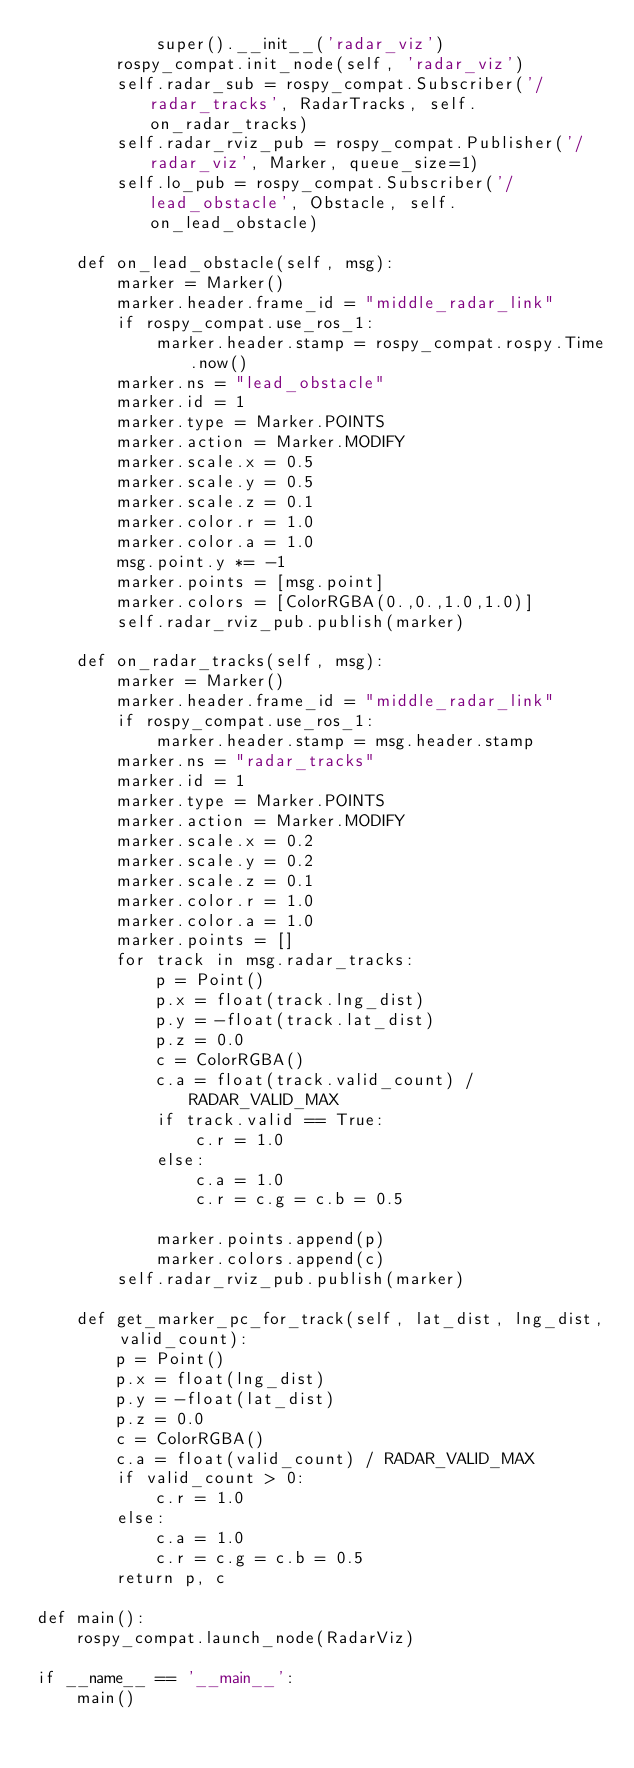<code> <loc_0><loc_0><loc_500><loc_500><_Python_>            super().__init__('radar_viz')
        rospy_compat.init_node(self, 'radar_viz')
        self.radar_sub = rospy_compat.Subscriber('/radar_tracks', RadarTracks, self.on_radar_tracks)
        self.radar_rviz_pub = rospy_compat.Publisher('/radar_viz', Marker, queue_size=1)
        self.lo_pub = rospy_compat.Subscriber('/lead_obstacle', Obstacle, self.on_lead_obstacle)

    def on_lead_obstacle(self, msg):
        marker = Marker()
        marker.header.frame_id = "middle_radar_link"
        if rospy_compat.use_ros_1:
            marker.header.stamp = rospy_compat.rospy.Time.now()
        marker.ns = "lead_obstacle"
        marker.id = 1
        marker.type = Marker.POINTS
        marker.action = Marker.MODIFY
        marker.scale.x = 0.5
        marker.scale.y = 0.5
        marker.scale.z = 0.1
        marker.color.r = 1.0
        marker.color.a = 1.0
        msg.point.y *= -1
        marker.points = [msg.point]
        marker.colors = [ColorRGBA(0.,0.,1.0,1.0)]
        self.radar_rviz_pub.publish(marker)

    def on_radar_tracks(self, msg):
        marker = Marker()
        marker.header.frame_id = "middle_radar_link"
        if rospy_compat.use_ros_1:
            marker.header.stamp = msg.header.stamp
        marker.ns = "radar_tracks"
        marker.id = 1
        marker.type = Marker.POINTS
        marker.action = Marker.MODIFY
        marker.scale.x = 0.2
        marker.scale.y = 0.2
        marker.scale.z = 0.1
        marker.color.r = 1.0
        marker.color.a = 1.0
        marker.points = []
        for track in msg.radar_tracks:
            p = Point()
            p.x = float(track.lng_dist)
            p.y = -float(track.lat_dist)
            p.z = 0.0
            c = ColorRGBA()
            c.a = float(track.valid_count) / RADAR_VALID_MAX
            if track.valid == True:
                c.r = 1.0
            else:
                c.a = 1.0
                c.r = c.g = c.b = 0.5

            marker.points.append(p)
            marker.colors.append(c)
        self.radar_rviz_pub.publish(marker)

    def get_marker_pc_for_track(self, lat_dist, lng_dist, valid_count):
        p = Point()
        p.x = float(lng_dist)
        p.y = -float(lat_dist)
        p.z = 0.0
        c = ColorRGBA()
        c.a = float(valid_count) / RADAR_VALID_MAX
        if valid_count > 0:
            c.r = 1.0
        else:
            c.a = 1.0
            c.r = c.g = c.b = 0.5
        return p, c

def main():
    rospy_compat.launch_node(RadarViz)

if __name__ == '__main__':
    main()
</code> 